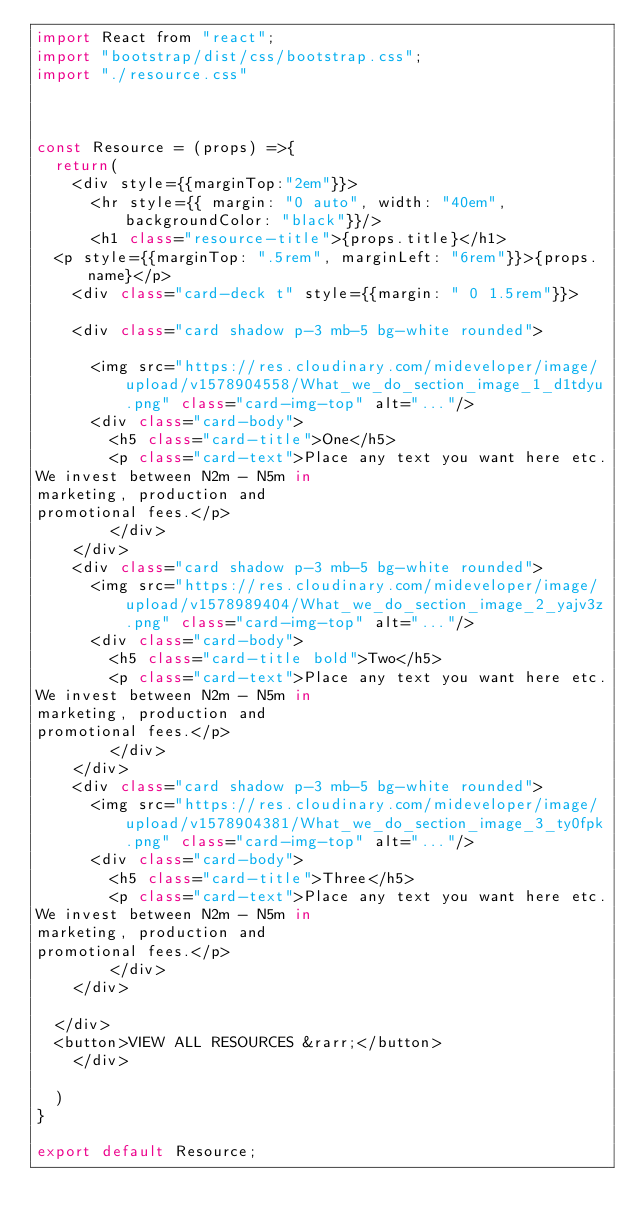<code> <loc_0><loc_0><loc_500><loc_500><_JavaScript_>import React from "react";
import "bootstrap/dist/css/bootstrap.css";
import "./resource.css"



const Resource = (props) =>{
  return(
    <div style={{marginTop:"2em"}}>
      <hr style={{ margin: "0 auto", width: "40em", backgroundColor: "black"}}/>
      <h1 class="resource-title">{props.title}</h1>
  <p style={{marginTop: ".5rem", marginLeft: "6rem"}}>{props.name}</p>
    <div class="card-deck t" style={{margin: " 0 1.5rem"}}>
   
    <div class="card shadow p-3 mb-5 bg-white rounded">
      
      <img src="https://res.cloudinary.com/mideveloper/image/upload/v1578904558/What_we_do_section_image_1_d1tdyu.png" class="card-img-top" alt="..."/>
      <div class="card-body">
        <h5 class="card-title">One</h5>
        <p class="card-text">Place any text you want here etc.
We invest between N2m - N5m in
marketing, production and
promotional fees.</p>
        </div>
    </div>
    <div class="card shadow p-3 mb-5 bg-white rounded">
      <img src="https://res.cloudinary.com/mideveloper/image/upload/v1578989404/What_we_do_section_image_2_yajv3z.png" class="card-img-top" alt="..."/>
      <div class="card-body">
        <h5 class="card-title bold">Two</h5>
        <p class="card-text">Place any text you want here etc.
We invest between N2m - N5m in
marketing, production and
promotional fees.</p>
        </div>
    </div>
    <div class="card shadow p-3 mb-5 bg-white rounded">
      <img src="https://res.cloudinary.com/mideveloper/image/upload/v1578904381/What_we_do_section_image_3_ty0fpk.png" class="card-img-top" alt="..."/>
      <div class="card-body">
        <h5 class="card-title">Three</h5>
        <p class="card-text">Place any text you want here etc.
We invest between N2m - N5m in
marketing, production and
promotional fees.</p>
        </div>
    </div>
    
  </div>
  <button>VIEW ALL RESOURCES &rarr;</button>
    </div>
    
  )
}

export default Resource;</code> 